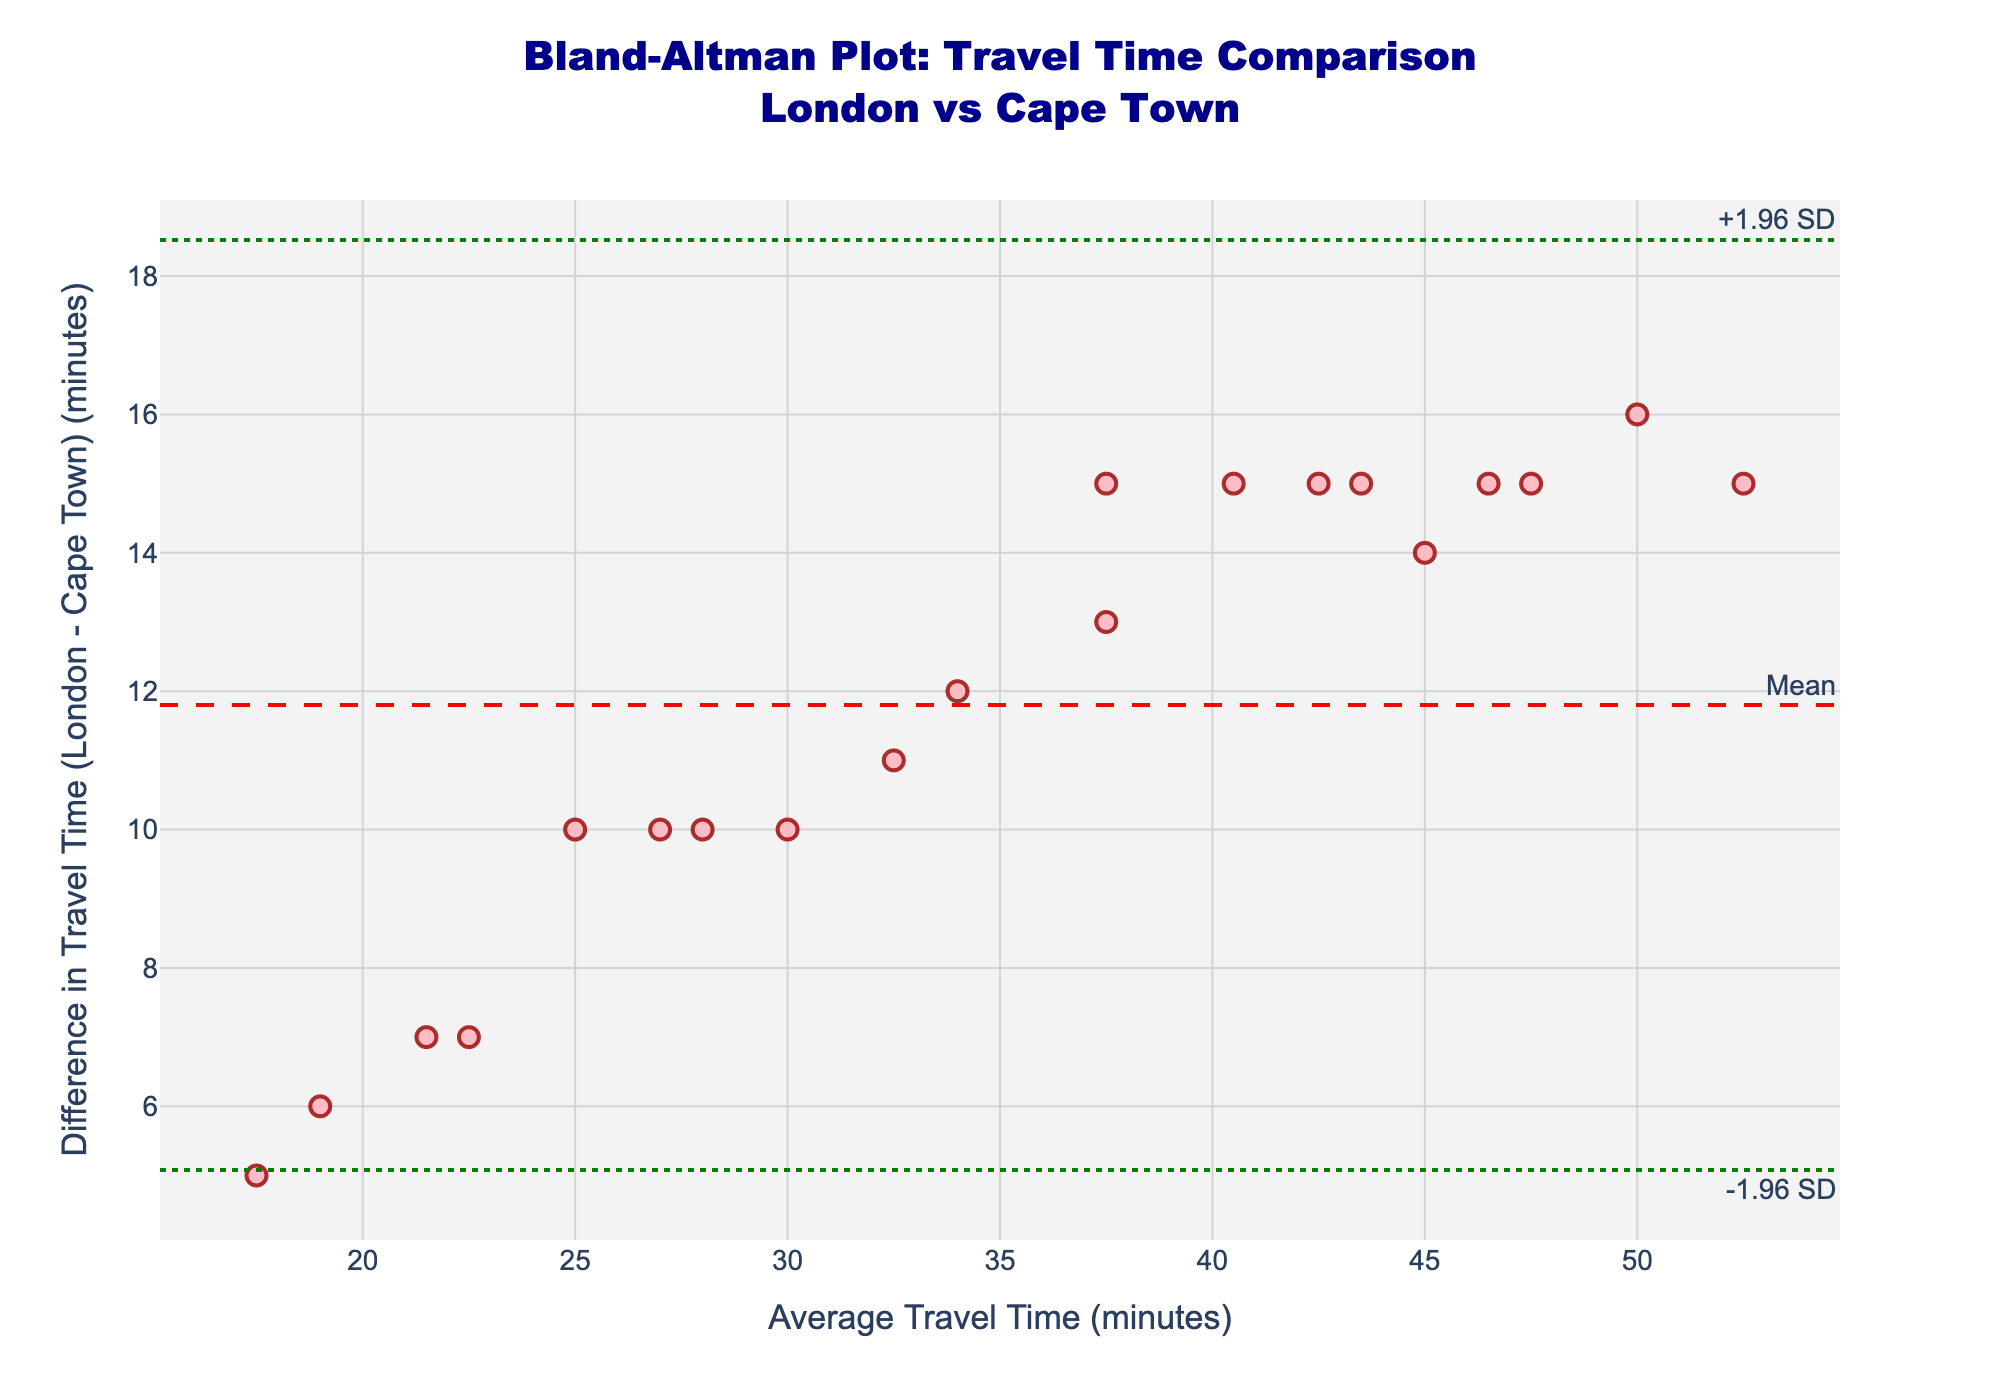What's the title of the plot? The title is displayed at the top of the figure and indicates the type of analysis and the cities compared.
Answer: "Bland-Altman Plot: Travel Time Comparison London vs Cape Town" How many data points are plotted? Count the number of markers (dots) on the plot. Each marker represents a data point. There should be 20 data points as there are 20 travel times listed in the data.
Answer: 20 What does the x-axis represent? The x-axis represents the average travel time, which is the mean of travel times for Cape Town and London. The axis label is "Average Travel Time (minutes)".
Answer: Average Travel Time What does the y-axis represent? The y-axis represents the difference in travel time, calculated as London travel time minus Cape Town travel time. The y-axis label is "Difference in Travel Time (London - Cape Town) (minutes)".
Answer: Difference in Travel Time What color are the data points? From the visual appearance of the markers (dots), they are mostly light pink with a darker outline.
Answer: Pink What is the measured mean difference in travel time between London and Cape Town? The mean difference is represented by the dashed red horizontal line on the plot. The text annotation next to this line reads "Mean".
Answer: Around 20 minutes What are the upper and lower limits of agreement? The green dotted horizontal lines represent the limits of agreement, labeled "+1.96 SD" and "-1.96 SD". These show the range within which most differences are expected to lie.
Answer: Upper and lower green lines What would you infer if most of the data points lie within the limits of agreement? This would indicate that most of the differences in travel times between Cape Town and London are within the expected range, suggesting consistency in the measured travel time differences.
Answer: Consistency within limits Do all data points fall within the limits of agreement? Observe the plot and check if all data points lie within the green dotted lines, which represent the limits of agreement.
Answer: Yes Is there any trend or pattern visible in the differences as the average travel time increases? Look for any visible trend or slope in the data points across the plot. Typically, you would assess if the differences increase or decrease as the average travel time increases. In this plot, differences seem fairly consistent and centered around the mean difference without a clear trend.
Answer: No clear trend 